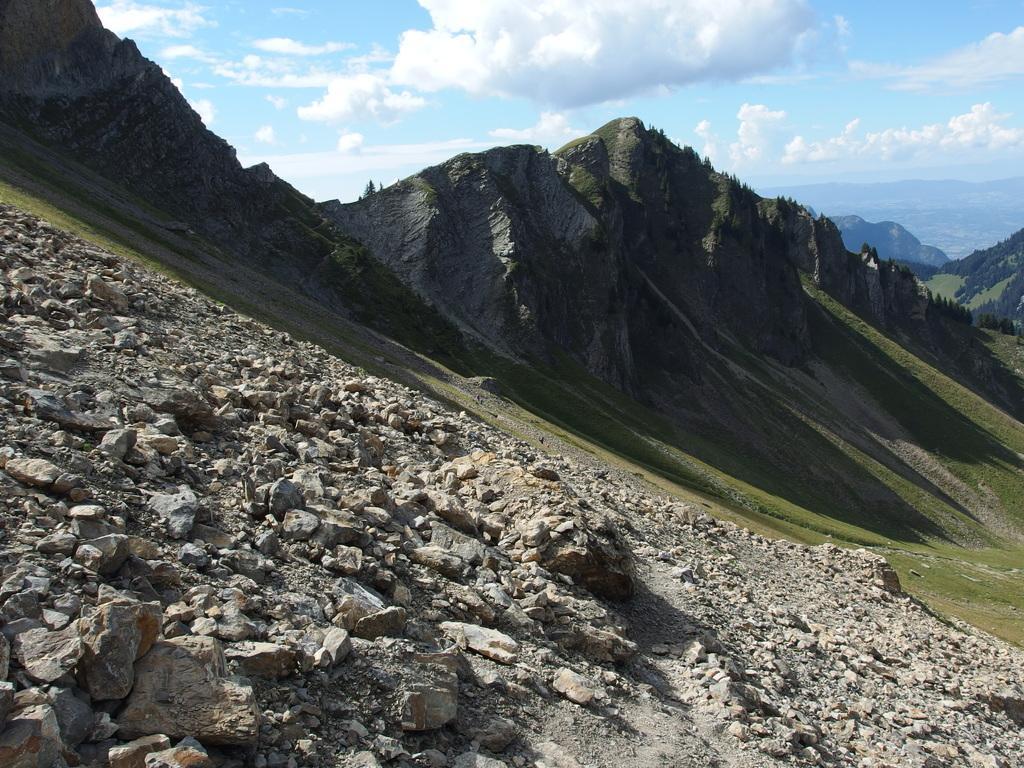Describe this image in one or two sentences. In the image we can see there are stones on the ground and behind there are hills. The ground is covered with grass and there is a cloudy sky. 